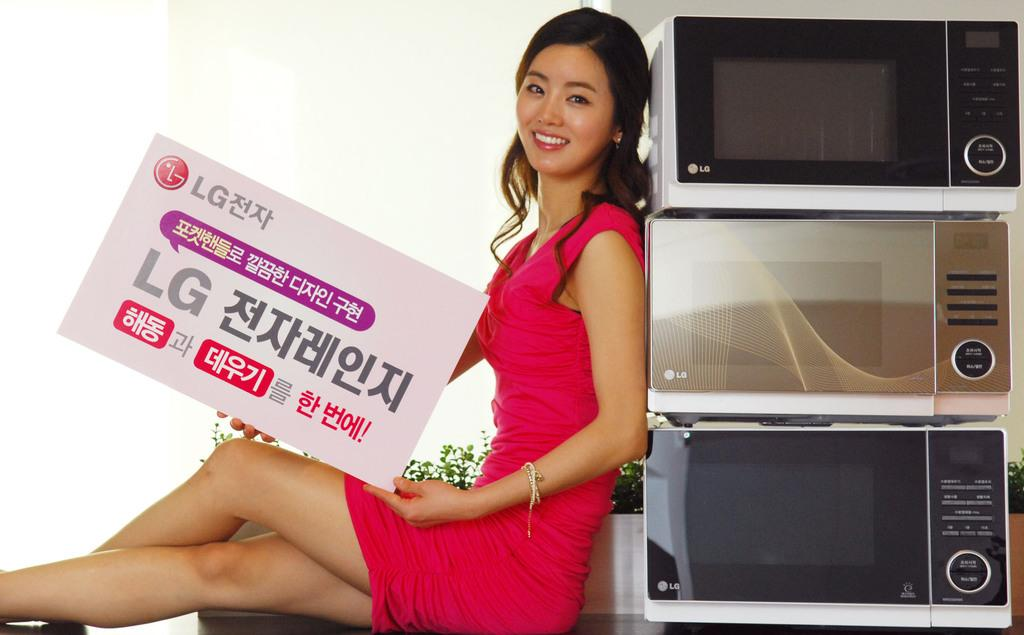<image>
Relay a brief, clear account of the picture shown. A woman leans up against 3 LG microwaves holding an LG sign with japanese letters written on it. 